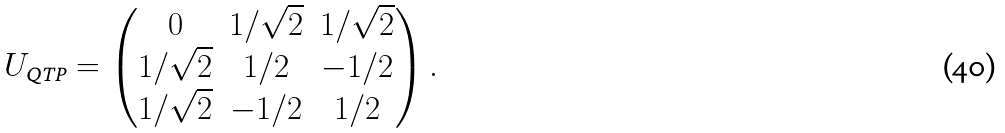Convert formula to latex. <formula><loc_0><loc_0><loc_500><loc_500>U _ { \text {QTP} } = \begin{pmatrix} 0 & 1 / \sqrt { 2 } & 1 / \sqrt { 2 } \\ 1 / \sqrt { 2 } & 1 / 2 & - 1 / 2 \\ 1 / \sqrt { 2 } & - 1 / 2 & 1 / 2 \end{pmatrix} .</formula> 